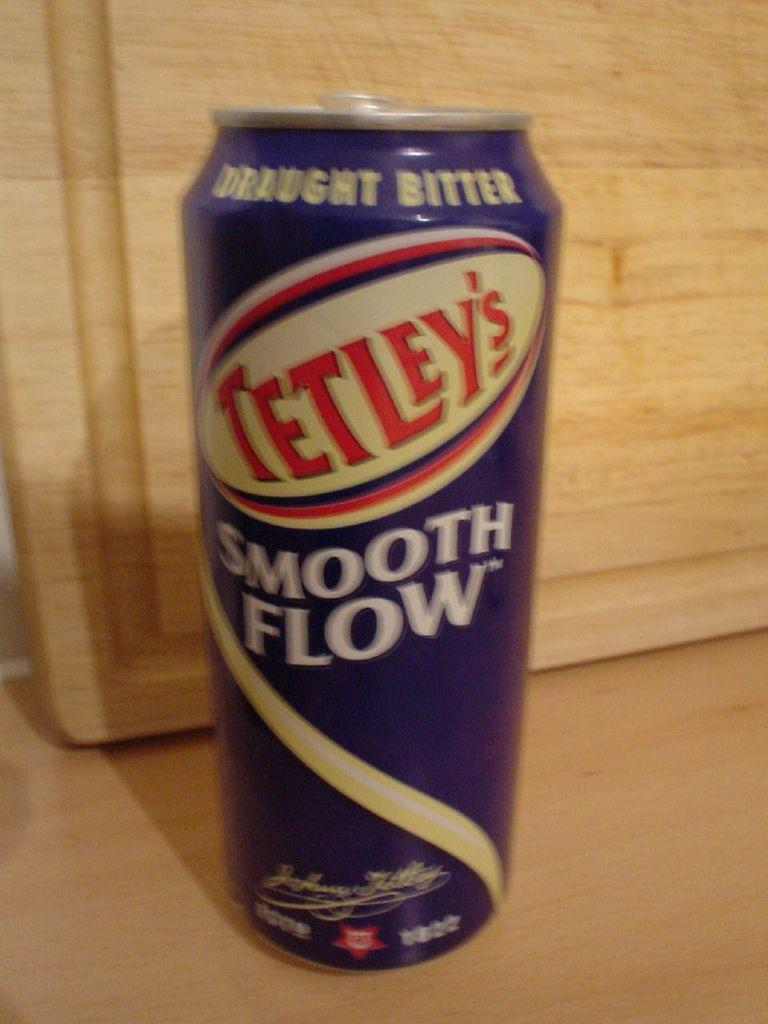<image>
Present a compact description of the photo's key features. A can of Tetley's draught bitter sits next to a wooden cutting board that is propped up. 